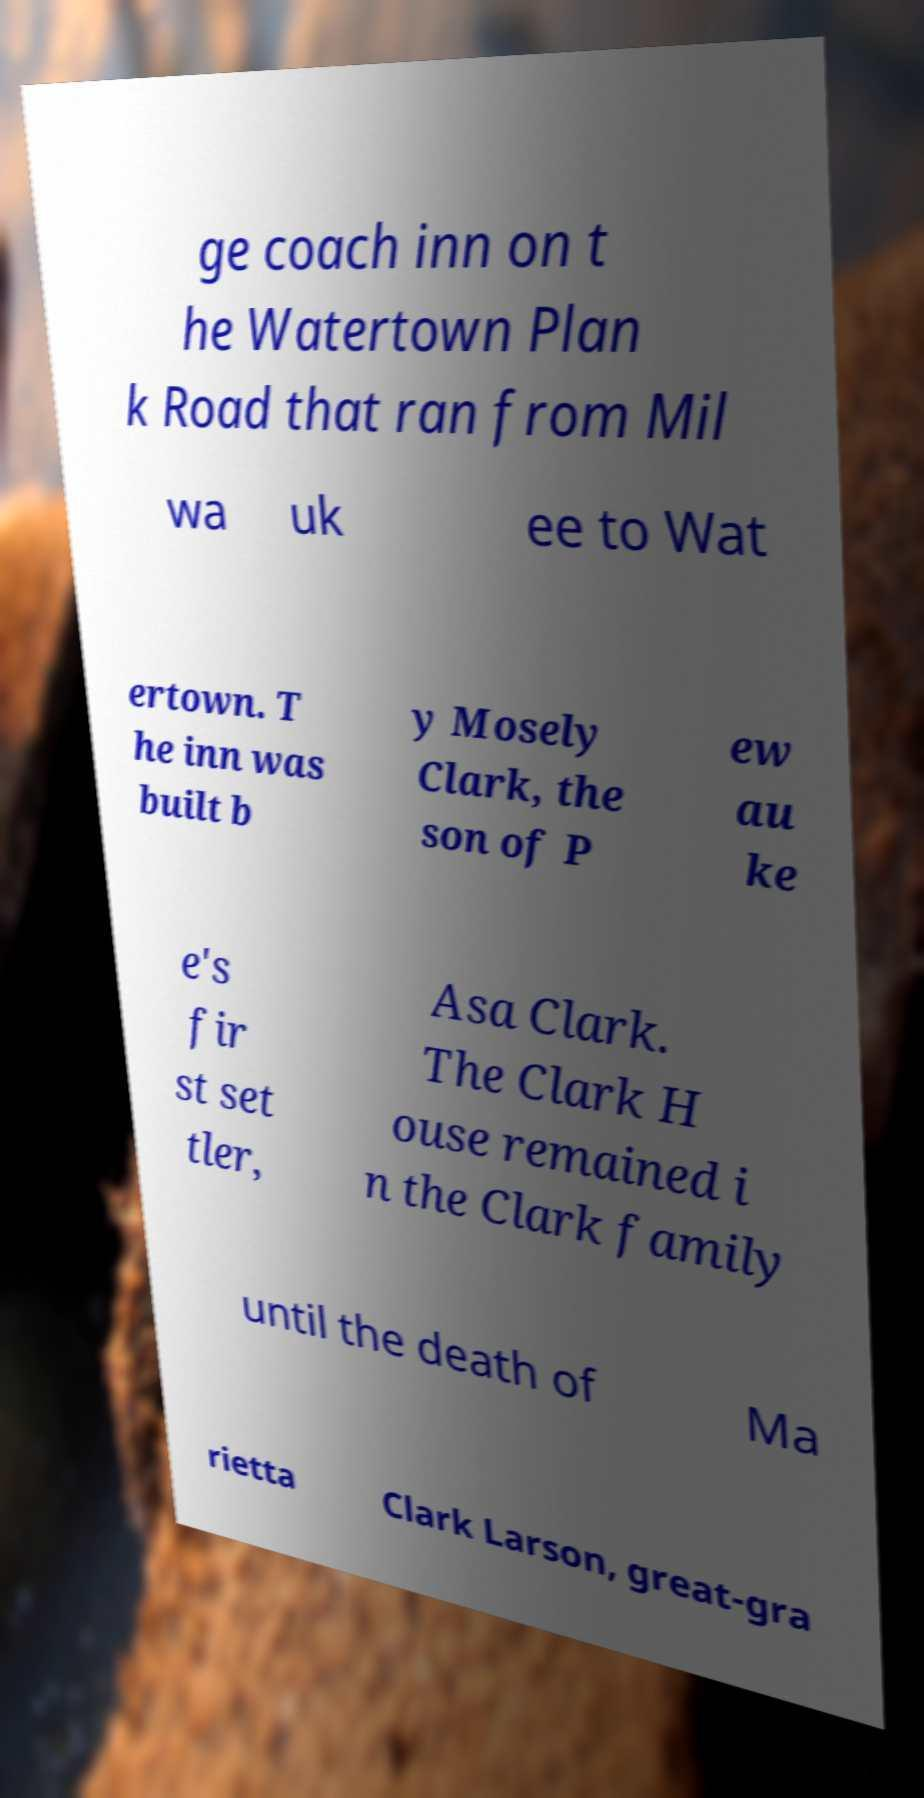I need the written content from this picture converted into text. Can you do that? ge coach inn on t he Watertown Plan k Road that ran from Mil wa uk ee to Wat ertown. T he inn was built b y Mosely Clark, the son of P ew au ke e's fir st set tler, Asa Clark. The Clark H ouse remained i n the Clark family until the death of Ma rietta Clark Larson, great-gra 